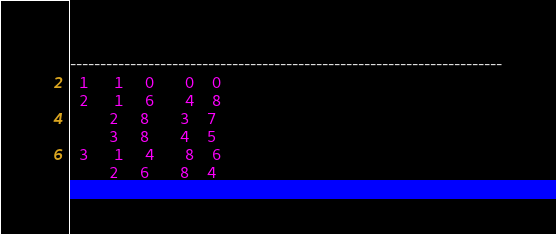<code> <loc_0><loc_0><loc_500><loc_500><_ObjectiveC_>------------------------------------------------------------------------
  1      1     0       0    0
  2      1     6       4    8
         2     8       3    7
         3     8       4    5
  3      1     4       8    6
         2     6       8    4</code> 